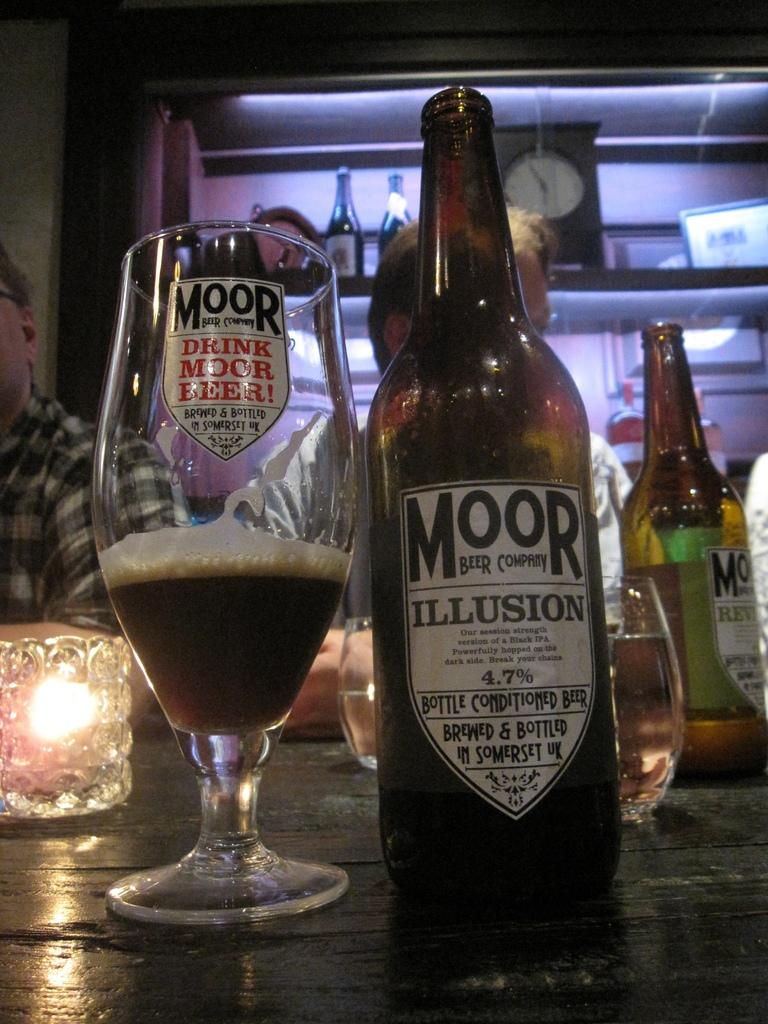<image>
Summarize the visual content of the image. A bottle of Illusion from the Moor beer company next to a quarter full glass. 